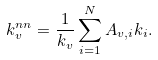Convert formula to latex. <formula><loc_0><loc_0><loc_500><loc_500>k ^ { n n } _ { v } = \frac { 1 } { k _ { v } } \sum _ { i = 1 } ^ { N } A _ { v , i } k _ { i } .</formula> 